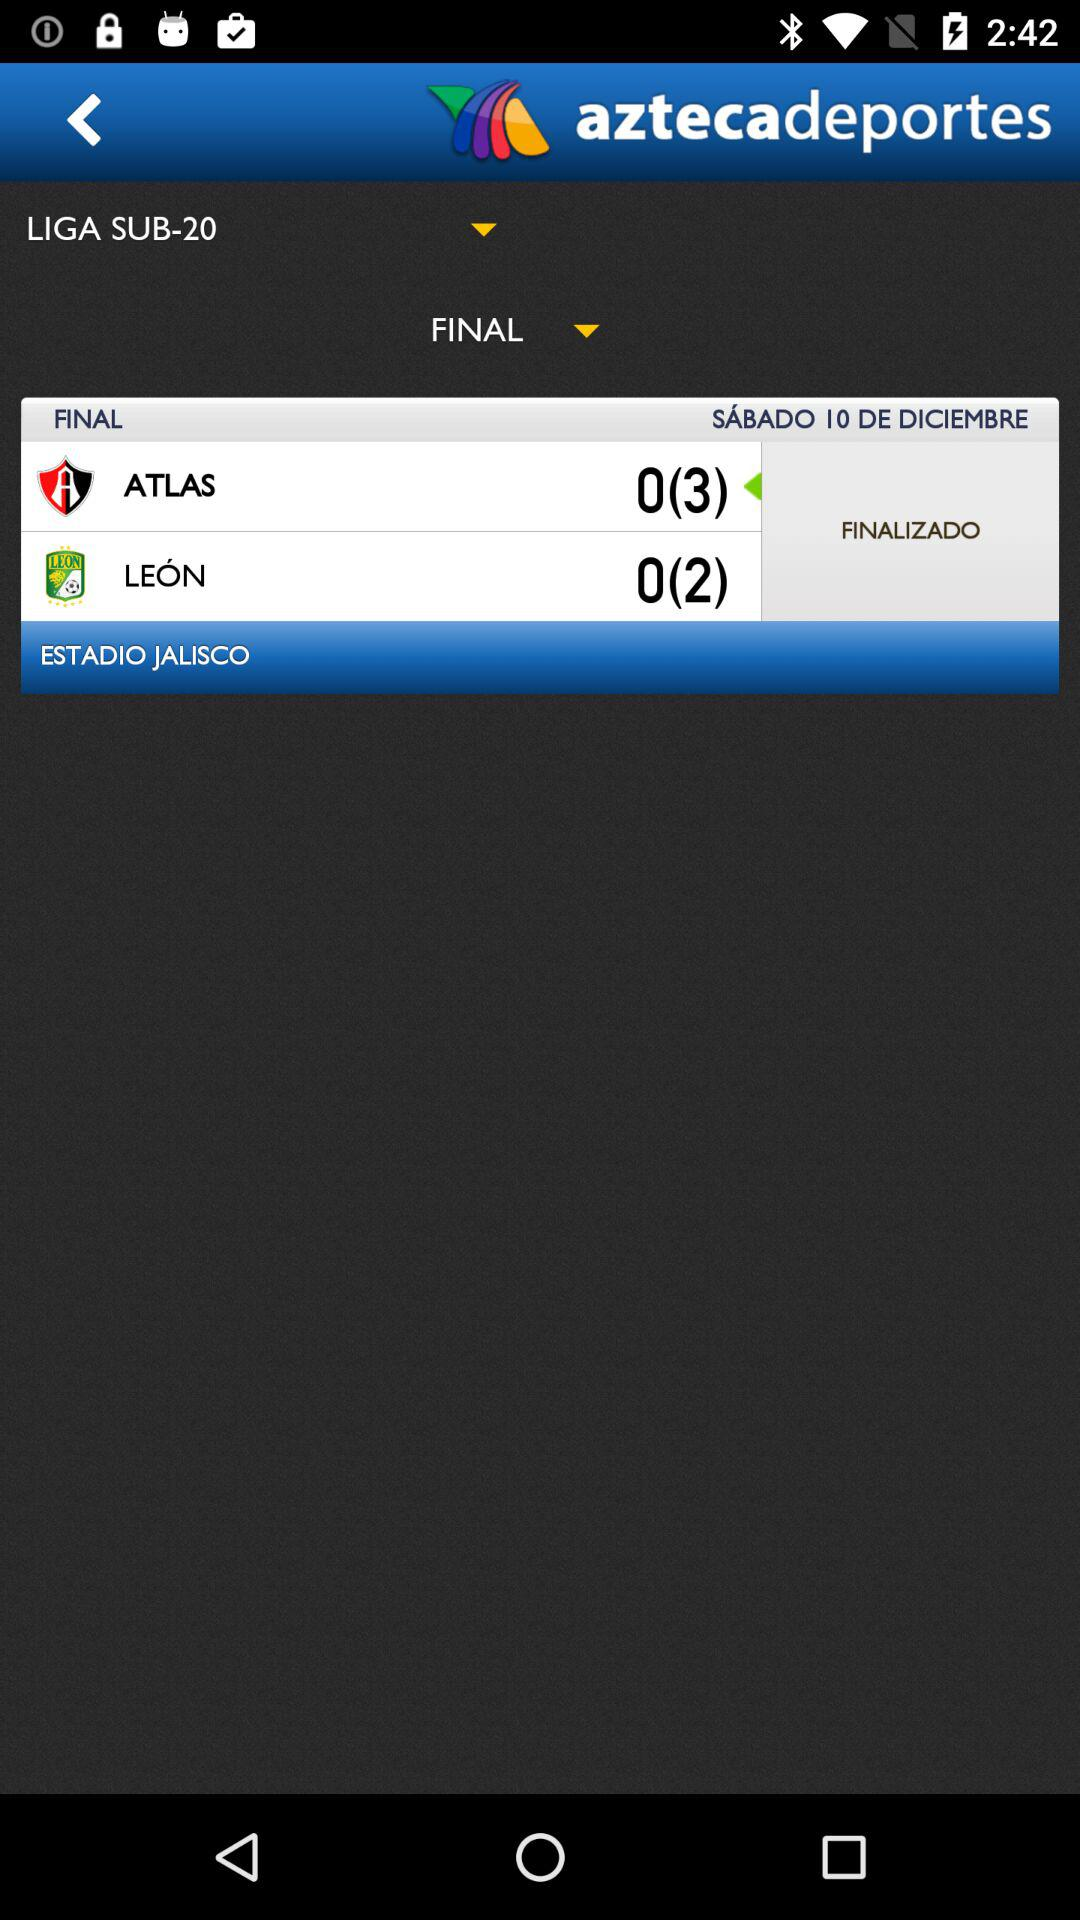How many more matches have been played by Atlas than León?
Answer the question using a single word or phrase. 1 